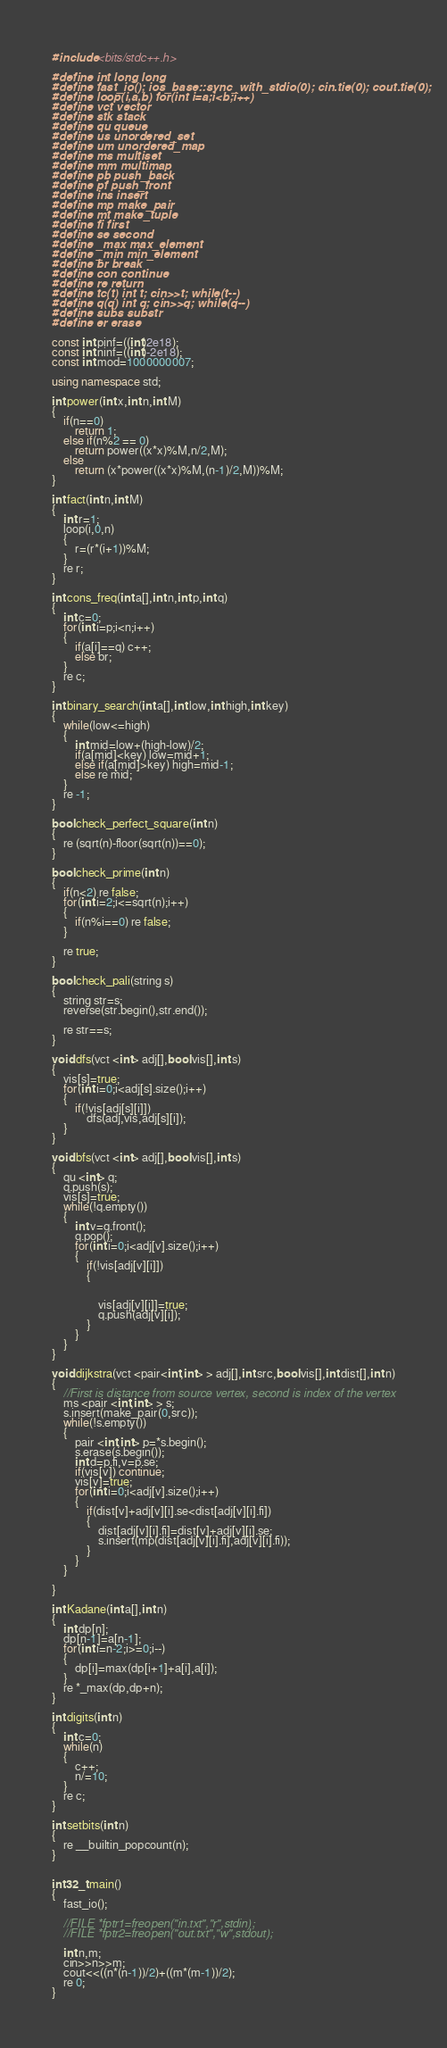Convert code to text. <code><loc_0><loc_0><loc_500><loc_500><_C++_>#include <bits/stdc++.h>

#define int long long
#define fast_io(); ios_base::sync_with_stdio(0); cin.tie(0); cout.tie(0);
#define loop(i,a,b) for(int i=a;i<b;i++)
#define vct vector
#define stk stack
#define qu queue
#define us unordered_set
#define um unordered_map
#define ms multiset
#define mm multimap
#define pb push_back
#define pf push_front
#define ins insert
#define mp make_pair
#define mt make_tuple
#define fi first
#define se second
#define _max max_element
#define _min min_element
#define br break
#define con continue
#define re return
#define tc(t) int t; cin>>t; while(t--)
#define q(q) int q; cin>>q; while(q--)
#define subs substr
#define er erase

const int pinf=((int)2e18);
const int ninf=((int)-2e18);
const int mod=1000000007;

using namespace std;

int power(int x,int n,int M)
{
    if(n==0)
        return 1;
    else if(n%2 == 0)
        return power((x*x)%M,n/2,M);
    else
        return (x*power((x*x)%M,(n-1)/2,M))%M;
}

int fact(int n,int M)
{
    int r=1;
    loop(i,0,n)
    {
        r=(r*(i+1))%M;
    }
    re r;
}

int cons_freq(int a[],int n,int p,int q)
{
    int c=0;
    for(int i=p;i<n;i++)
    {
        if(a[i]==q) c++;
        else br;
    }
    re c;
}

int binary_search(int a[],int low,int high,int key)
{
    while(low<=high)
    {
        int mid=low+(high-low)/2;
        if(a[mid]<key) low=mid+1;
        else if(a[mid]>key) high=mid-1;
        else re mid;
    }
    re -1;
}

bool check_perfect_square(int n)
{
    re (sqrt(n)-floor(sqrt(n))==0);
}

bool check_prime(int n)
{
    if(n<2) re false;
    for(int i=2;i<=sqrt(n);i++)
    {
        if(n%i==0) re false;
    }

    re true;
}

bool check_pali(string s)
{
    string str=s;
    reverse(str.begin(),str.end());

    re str==s;
}

void dfs(vct <int> adj[],bool vis[],int s)
{
    vis[s]=true;
    for(int i=0;i<adj[s].size();i++)
    {
        if(!vis[adj[s][i]])
            dfs(adj,vis,adj[s][i]);
    }
}

void bfs(vct <int> adj[],bool vis[],int s)
{
    qu <int> q;
    q.push(s);
    vis[s]=true;
    while(!q.empty())
    {
        int v=q.front();
        q.pop();
        for(int i=0;i<adj[v].size();i++)
        {
            if(!vis[adj[v][i]])
            {


                vis[adj[v][i]]=true;
                q.push(adj[v][i]);
            }
        }
    }
}

void dijkstra(vct <pair<int,int> > adj[],int src,bool vis[],int dist[],int n)
{
    //First is distance from source vertex, second is index of the vertex
    ms <pair <int,int> > s;
    s.insert(make_pair(0,src));
    while(!s.empty())
    {
        pair <int,int> p=*s.begin();
        s.erase(s.begin());
        int d=p.fi,v=p.se;
        if(vis[v]) continue;
        vis[v]=true;
        for(int i=0;i<adj[v].size();i++)
        {
            if(dist[v]+adj[v][i].se<dist[adj[v][i].fi])
            {
                dist[adj[v][i].fi]=dist[v]+adj[v][i].se;
                s.insert(mp(dist[adj[v][i].fi],adj[v][i].fi));
            }
        }
    }

}

int Kadane(int a[],int n)
{
    int dp[n];
    dp[n-1]=a[n-1];
    for(int i=n-2;i>=0;i--)
    {
        dp[i]=max(dp[i+1]+a[i],a[i]);
    }
    re *_max(dp,dp+n);
}

int digits(int n)
{
    int c=0;
    while(n)
    {
        c++;
        n/=10;
    }
    re c;
}

int setbits(int n)
{
    re __builtin_popcount(n);
}


int32_t main()
{
    fast_io();

    //FILE *fptr1=freopen("in.txt","r",stdin);
    //FILE *fptr2=freopen("out.txt","w",stdout);

    int n,m;
    cin>>n>>m;
    cout<<((n*(n-1))/2)+((m*(m-1))/2);
    re 0;
}
</code> 